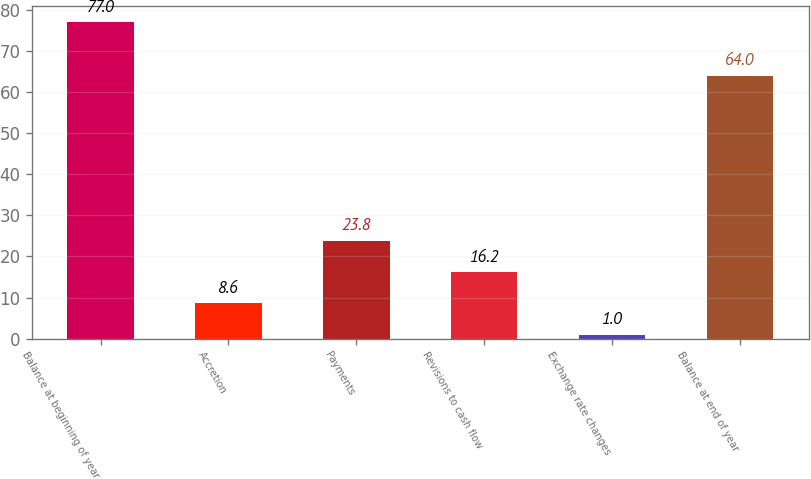Convert chart to OTSL. <chart><loc_0><loc_0><loc_500><loc_500><bar_chart><fcel>Balance at beginning of year<fcel>Accretion<fcel>Payments<fcel>Revisions to cash flow<fcel>Exchange rate changes<fcel>Balance at end of year<nl><fcel>77<fcel>8.6<fcel>23.8<fcel>16.2<fcel>1<fcel>64<nl></chart> 